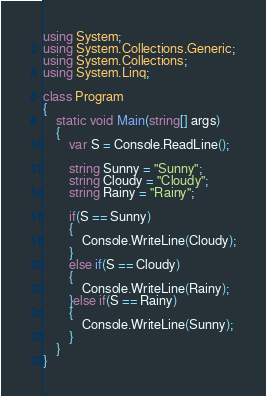Convert code to text. <code><loc_0><loc_0><loc_500><loc_500><_C#_>using System;
using System.Collections.Generic;
using System.Collections;
using System.Linq;

class Program
{
    static void Main(string[] args)
    {
        var S = Console.ReadLine();

        string Sunny = "Sunny";
        string Cloudy = "Cloudy";
        string Rainy = "Rainy";

        if(S == Sunny)
        {
            Console.WriteLine(Cloudy);
        }
        else if(S == Cloudy)
        {
            Console.WriteLine(Rainy);
        }else if(S == Rainy)
        {
            Console.WriteLine(Sunny);
        }
    }
}</code> 